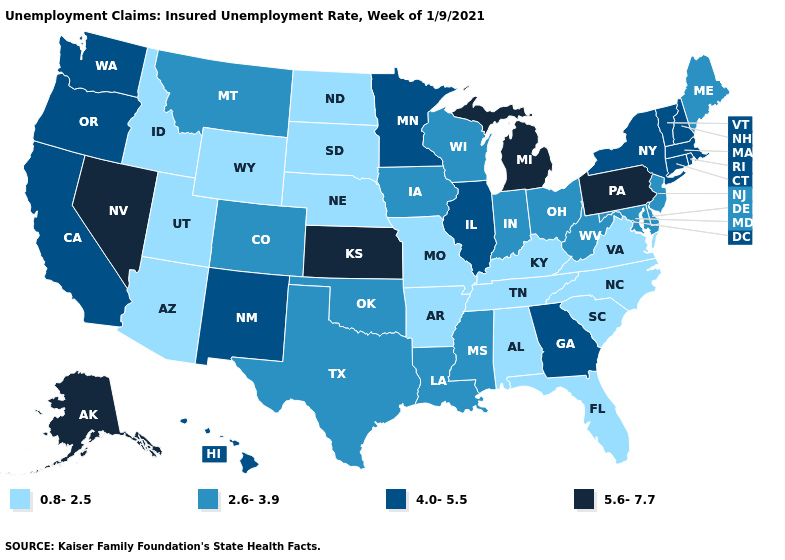What is the value of Texas?
Be succinct. 2.6-3.9. Which states have the highest value in the USA?
Answer briefly. Alaska, Kansas, Michigan, Nevada, Pennsylvania. Does Oregon have the lowest value in the USA?
Concise answer only. No. What is the lowest value in the Northeast?
Give a very brief answer. 2.6-3.9. Does Mississippi have a lower value than Michigan?
Keep it brief. Yes. What is the value of Colorado?
Write a very short answer. 2.6-3.9. What is the lowest value in states that border Missouri?
Concise answer only. 0.8-2.5. What is the value of Utah?
Concise answer only. 0.8-2.5. Name the states that have a value in the range 5.6-7.7?
Quick response, please. Alaska, Kansas, Michigan, Nevada, Pennsylvania. How many symbols are there in the legend?
Be succinct. 4. What is the highest value in the USA?
Keep it brief. 5.6-7.7. Name the states that have a value in the range 5.6-7.7?
Be succinct. Alaska, Kansas, Michigan, Nevada, Pennsylvania. What is the value of Massachusetts?
Short answer required. 4.0-5.5. Name the states that have a value in the range 0.8-2.5?
Keep it brief. Alabama, Arizona, Arkansas, Florida, Idaho, Kentucky, Missouri, Nebraska, North Carolina, North Dakota, South Carolina, South Dakota, Tennessee, Utah, Virginia, Wyoming. 